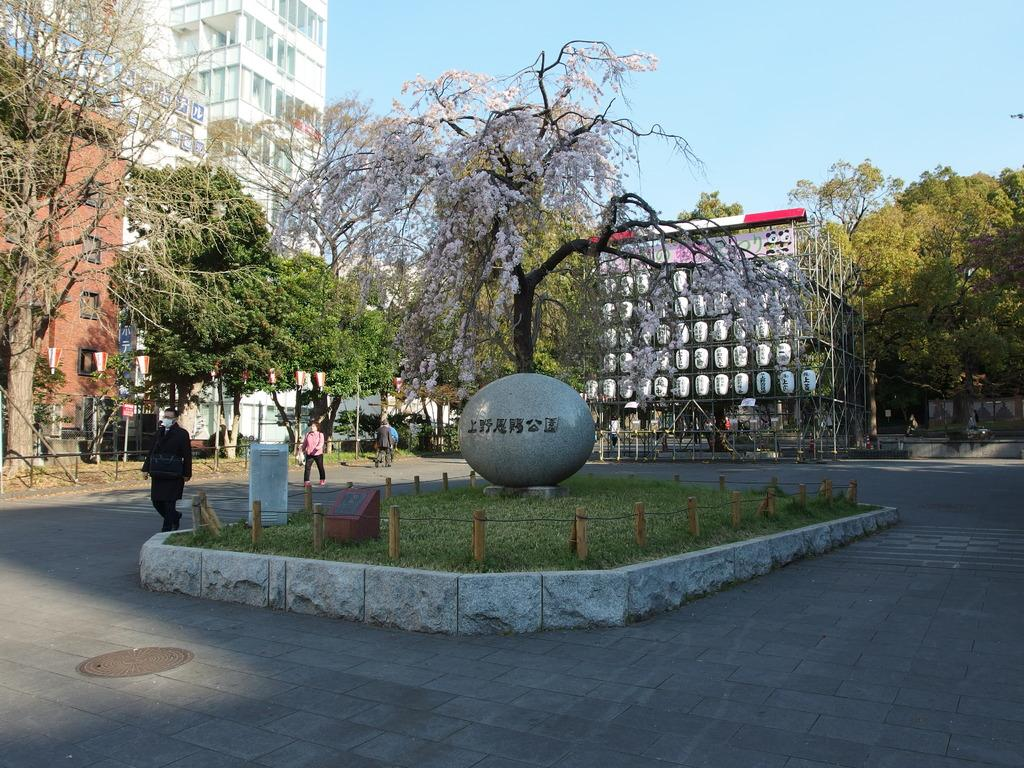What are the people in the image doing? The people in the image are walking on the road. What can be seen in the background of the image? There are buildings, trees, and the sky visible in the background of the image. What type of frogs can be seen jumping on the table in the image? There are no frogs or tables present in the image. 